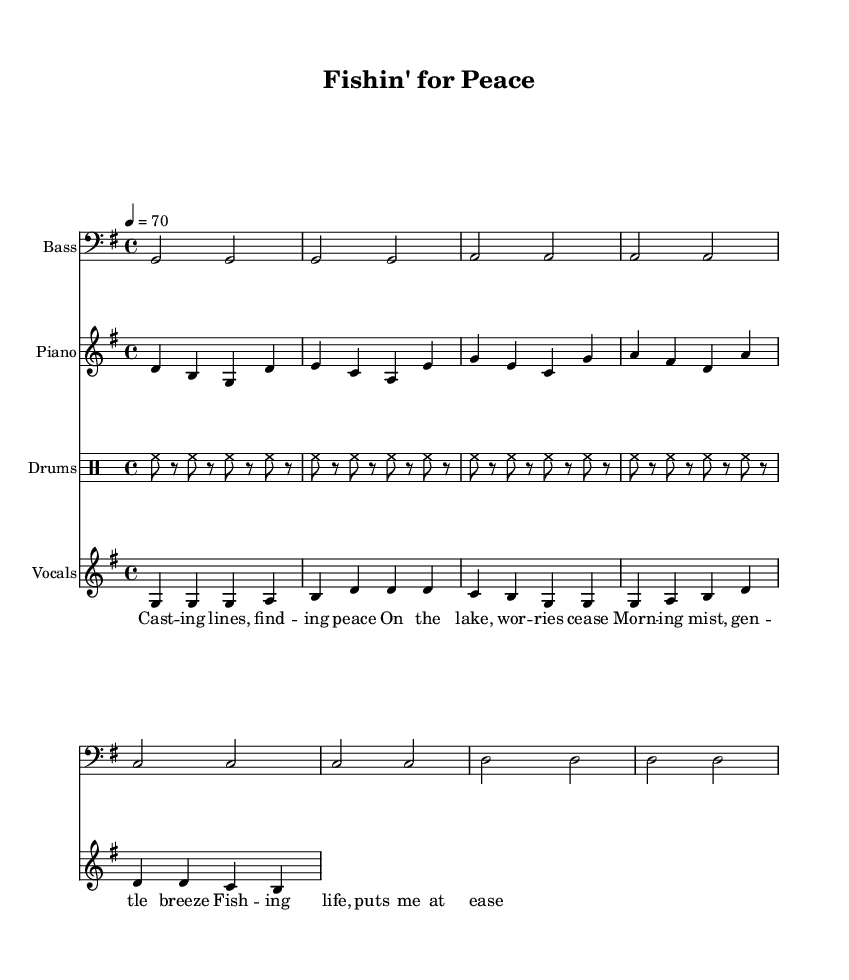What is the key signature of this music? The key signature is G major, indicated by one sharp (F#) which appears at the beginning of the staff.
Answer: G major What is the time signature of this music? The time signature is 4/4, which is shown at the beginning of the sheet music, indicating four beats per measure.
Answer: 4/4 What is the tempo marking of this piece? The tempo marking shows a quarter note equals 70, indicating the speed at which the piece should be played.
Answer: 70 What instruments are used in this composition? The instruments listed on the score include Bass, Piano, Drums, and Vocals, each specified at the start of their respective staffs.
Answer: Bass, Piano, Drums, and Vocals How many measures are in the bass section? The bass section contains four measures; we can count four groups of four beats each in the bass notation.
Answer: 4 What genre does this piece represent? The piece represents the Hip Hop genre, as indicated by its laid-back style and focus on themes of fishing and tranquility.
Answer: Hip Hop What is the main theme expressed in the lyrics? The lyrics express a theme of finding peace and tranquility while fishing, highlighting moments of relaxation and connection with nature.
Answer: Peace and tranquility 